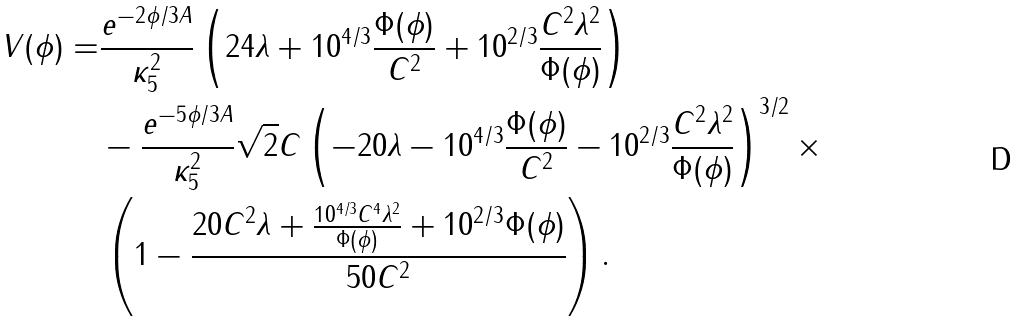<formula> <loc_0><loc_0><loc_500><loc_500>V ( \phi ) = & \frac { e ^ { - 2 \phi / 3 A } } { \kappa _ { 5 } ^ { 2 } } \left ( 2 4 \lambda + 1 0 ^ { 4 / 3 } \frac { \Phi ( \phi ) } { C ^ { 2 } } + 1 0 ^ { 2 / 3 } \frac { C ^ { 2 } \lambda ^ { 2 } } { \Phi ( \phi ) } \right ) \\ & - \frac { e ^ { - 5 \phi / 3 A } } { \kappa _ { 5 } ^ { 2 } } \sqrt { 2 } C \left ( - 2 0 \lambda - 1 0 ^ { 4 / 3 } \frac { \Phi ( \phi ) } { C ^ { 2 } } - 1 0 ^ { 2 / 3 } \frac { C ^ { 2 } \lambda ^ { 2 } } { \Phi ( \phi ) } \right ) ^ { 3 / 2 } \times \\ & \left ( 1 - \frac { 2 0 C ^ { 2 } \lambda + \frac { 1 0 ^ { 4 / 3 } C ^ { 4 } \lambda ^ { 2 } } { \Phi ( \phi ) } + 1 0 ^ { 2 / 3 } \Phi ( \phi ) } { 5 0 C ^ { 2 } } \right ) .</formula> 